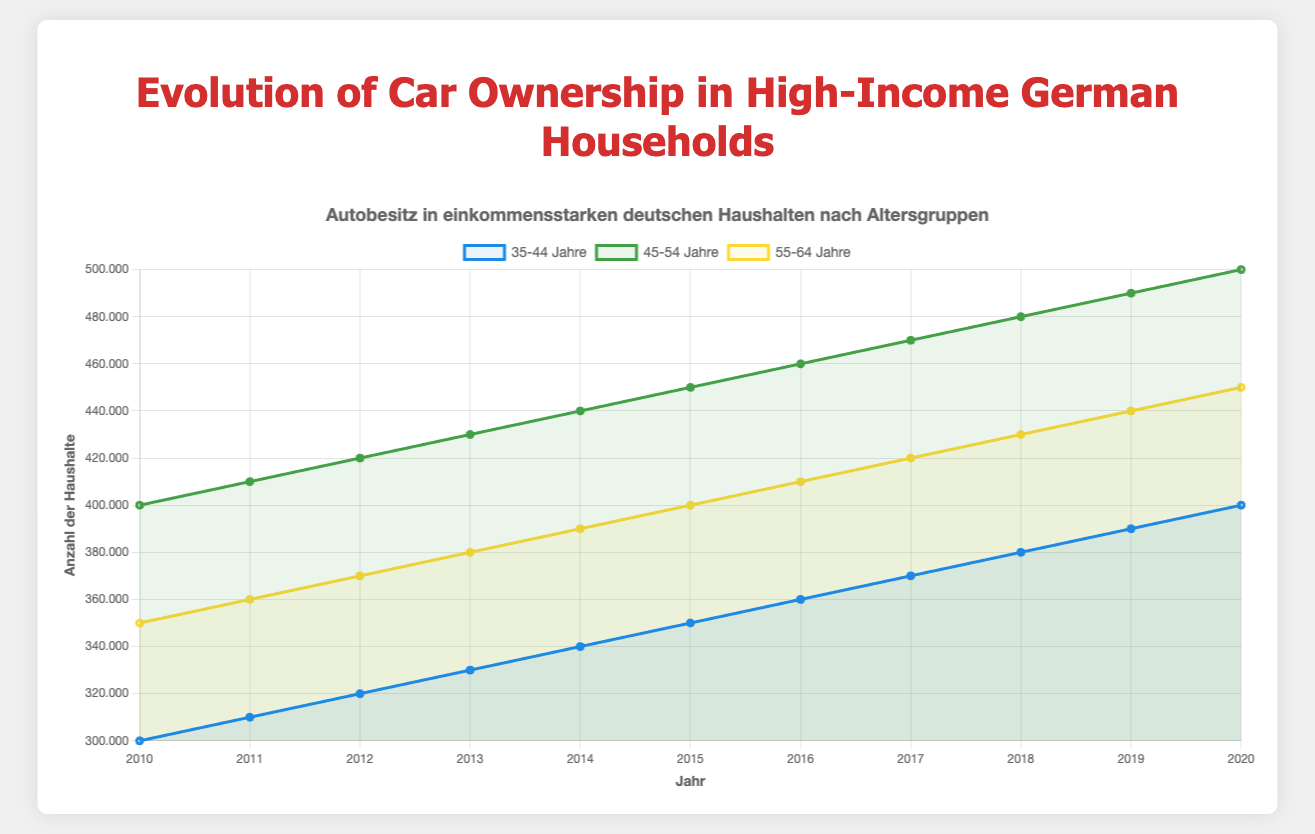What is the trend in car ownership for high-income households in the 45-54 age group from 2010 to 2020? To determine the trend, look at the line representing the 45-54 age group, which is green. The values for high-income households increase consistently from 400,000 in 2010 to 500,000 in 2020, indicating an upward trend.
Answer: Upward trend Which age group had the highest increase in high-income household car ownership between 2010 and 2020? Calculate the increase for each age group: 
- Age 35-44: 400,000 (2020) - 300,000 (2010) = 100,000
- Age 45-54: 500,000 (2020) - 400,000 (2010) = 100,000
- Age 55-64: 450,000 (2020) - 350,000 (2010) = 100,000 
Since all age groups had an increase of 100,000, no single group had the highest increase.
Answer: No single group, all had 100,000 increase Which year saw the highest number of high-income household car ownership in the 55-64 age group? Identify the highest point on the yellow line representing 55-64 high-income household car ownership. The highest number is 450,000, which occurs in 2020.
Answer: 2020 In 2015, how many more high-income households in the 45-54 age group owned cars compared to the 35-44 age group? Subtract the number of high-income 35-44 year-old households from the number of high-income 45-54 year old households in 2015:
450,000 (45-54) - 350,000 (35-44) = 100,000.
Answer: 100,000 What's the average car ownership in high-income households for the 35-44 age group over the period 2010-2020? Sum the values for the 35-44 age group from 2010 to 2020 and then divide by the number of years (11). 
(300,000 + 310,000 + 320,000 + 330,000 + 340,000 + 350,000 + 360,000 + 370,000 + 380,000 + 390,000 + 400,000) / 11 = 350,000.
Answer: 350,000 In which year did the 45-54 age group's high-income households surpass 450,000 car owners? Find the first year where the green line (45-54 age group) surpasses 450,000. It first surpasses this threshold in 2016, with 460,000.
Answer: 2016 By how much did car ownership in high-income households for the 55-64 age group increase from 2016 to 2020? Subtract the value in 2016 from the value in 2020 for the 55-64 age group:
450,000 - 410,000 = 40,000.
Answer: 40,000 Which age group showed the most significant growth in high-income household car ownership from 2010 to 2015? Calculate the growth for each group from 2010 to 2015:
- Age 35-44: 350,000 (2015) - 300,000 (2010) = 50,000
- Age 45-54: 450,000 (2015) - 400,000 (2010) = 50,000
- Age 55-64: 400,000 (2015) - 350,000 (2010) = 50,000 
All groups grew by 50,000, so no single age group showed the most significant growth.
Answer: All groups grew equally by 50,000 